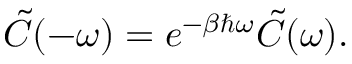Convert formula to latex. <formula><loc_0><loc_0><loc_500><loc_500>\begin{array} { r } { \tilde { C } ( - \omega ) = e ^ { - \beta \hbar { \omega } } \tilde { C } ( \omega ) . } \end{array}</formula> 